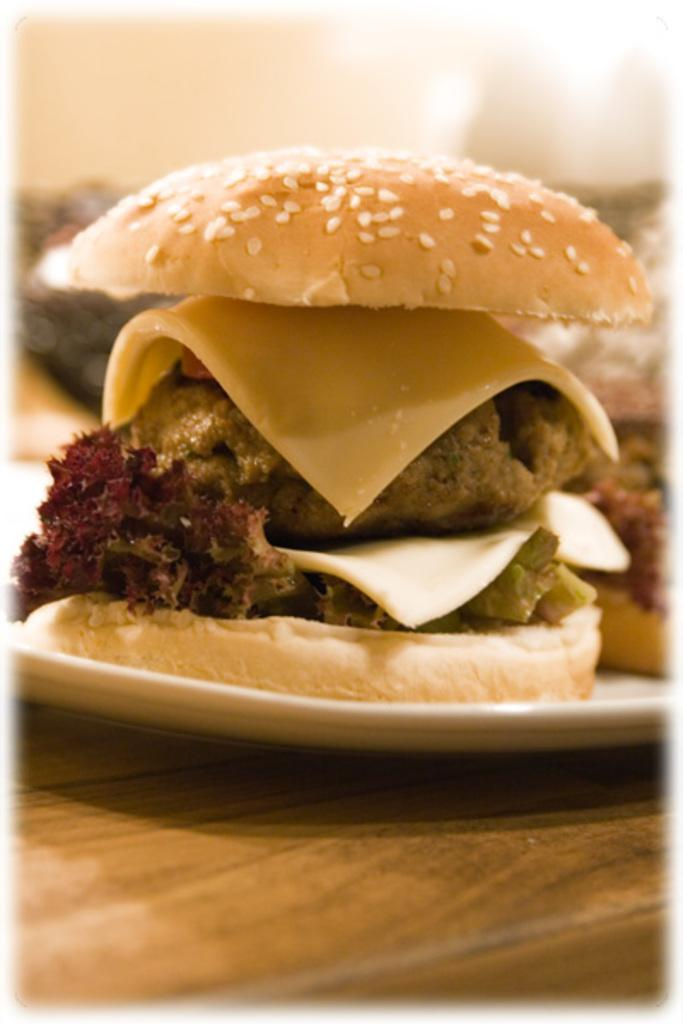What can be seen on the plate in the image? There is food on the plate in the image. Can you describe the type of food on the plate? Unfortunately, the specific type of food cannot be determined from the provided facts. What type of leather is being used to make waves in the image? There is no leather or waves present in the image. 